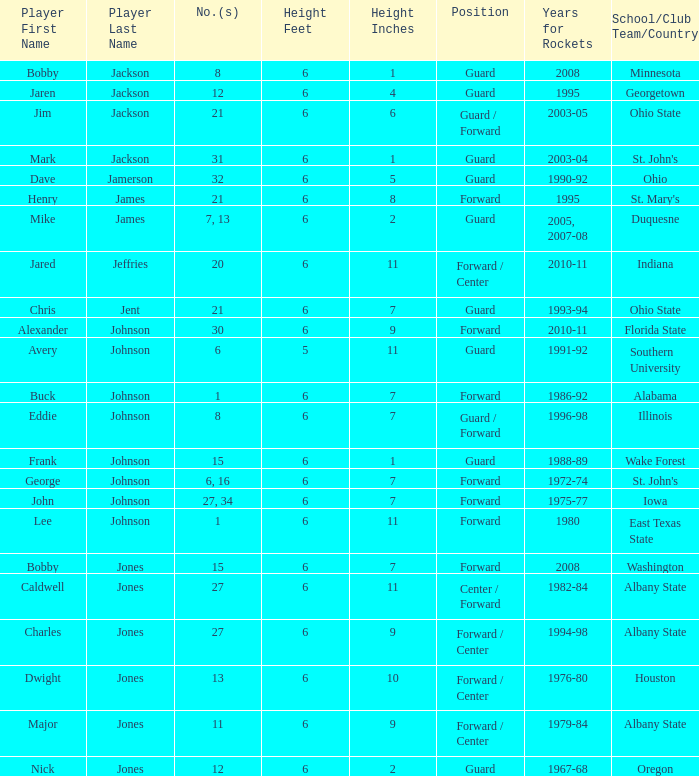How tall is the player jones, major major jones? 6-9. 